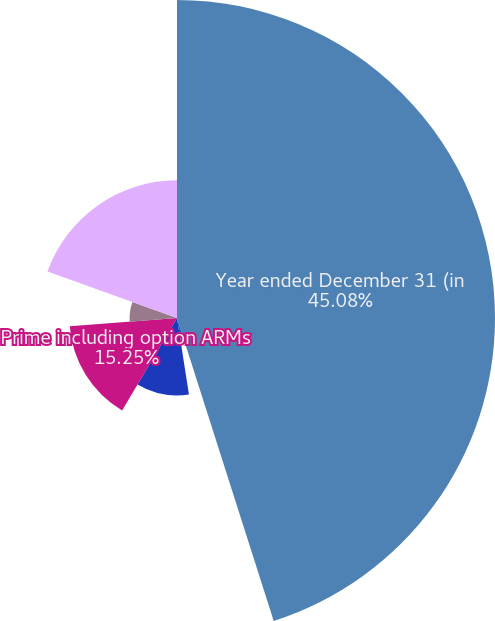Convert chart. <chart><loc_0><loc_0><loc_500><loc_500><pie_chart><fcel>Year ended December 31 (in<fcel>Senior lien<fcel>Junior lien<fcel>Prime including option ARMs<fcel>Subprime<fcel>Total residential real estate<nl><fcel>45.08%<fcel>2.46%<fcel>10.98%<fcel>15.25%<fcel>6.72%<fcel>19.51%<nl></chart> 